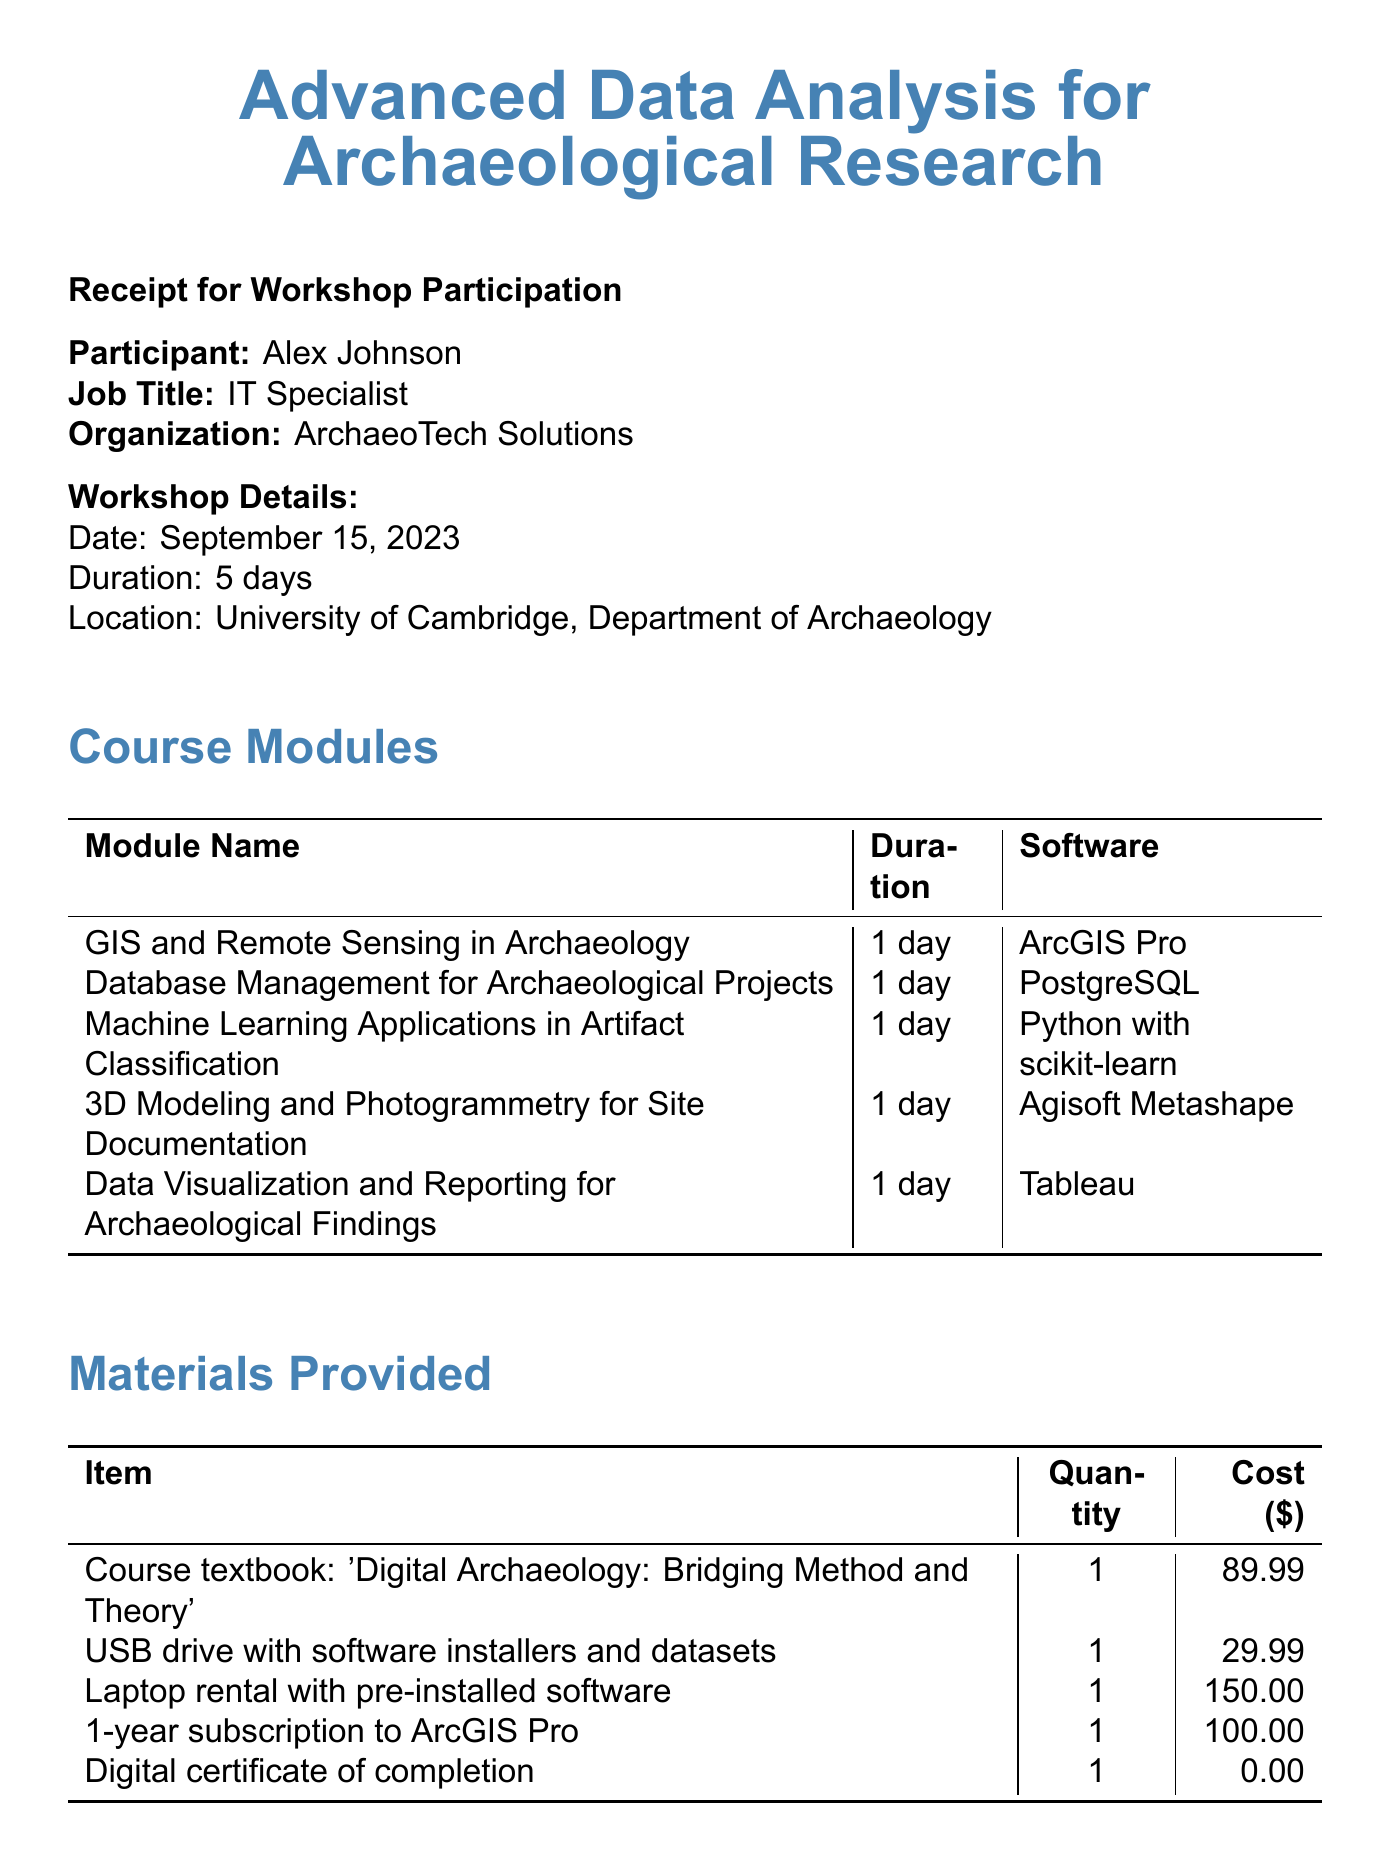What is the workshop name? The workshop name is specified at the top of the document.
Answer: Advanced Data Analysis for Archaeological Research What is the date of the workshop? The date is mentioned under the workshop details section.
Answer: September 15, 2023 How many days does the workshop last? The duration is indicated in the workshop details.
Answer: 5 days What is the total cost of the workshop? The total cost is stated in the payment details section.
Answer: $1,299.99 Which software is used for the GIS and Remote Sensing module? The software for this module is listed in the course modules section.
Answer: ArcGIS Pro What item is provided as a digital certificate? The document lists this item under materials provided.
Answer: Digital certificate of completion How many nights of accommodation are included? This information can be found in the additional services section.
Answer: 4 nights What is the cost of catered lunches and refreshments? This information is mentioned under additional services.
Answer: $75.00 What payment method was used? The payment method is outlined in the payment details section.
Answer: Credit Card (Visa) 